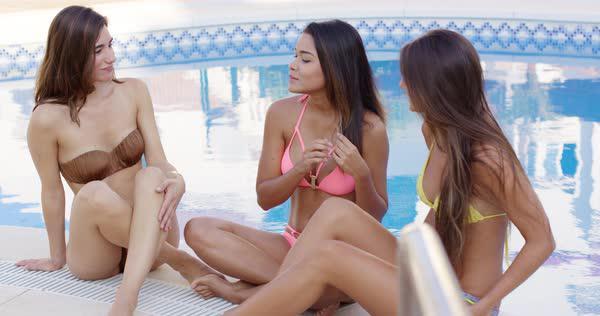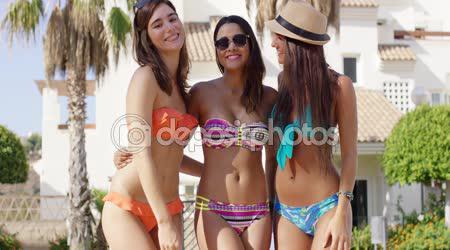The first image is the image on the left, the second image is the image on the right. Analyze the images presented: Is the assertion "An image shows three bikini models side-by-side with backs turned to the camera." valid? Answer yes or no. No. 